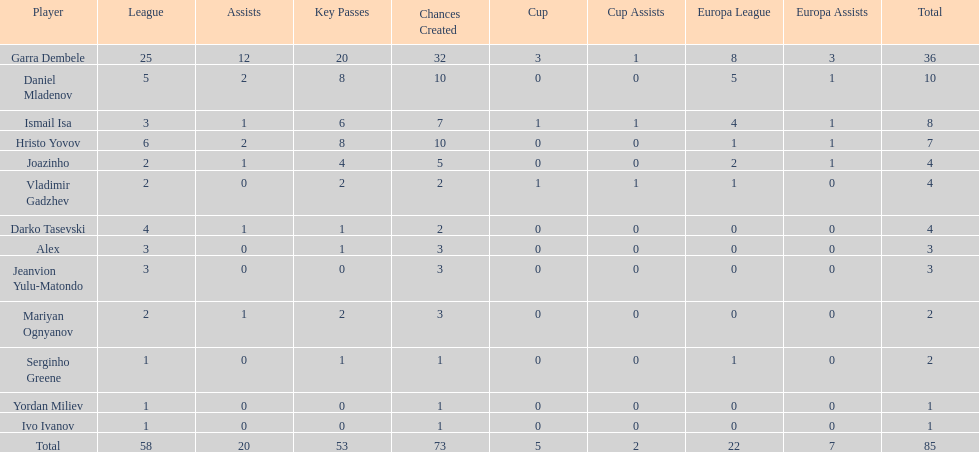Which total is higher, the europa league total or the league total? League. 